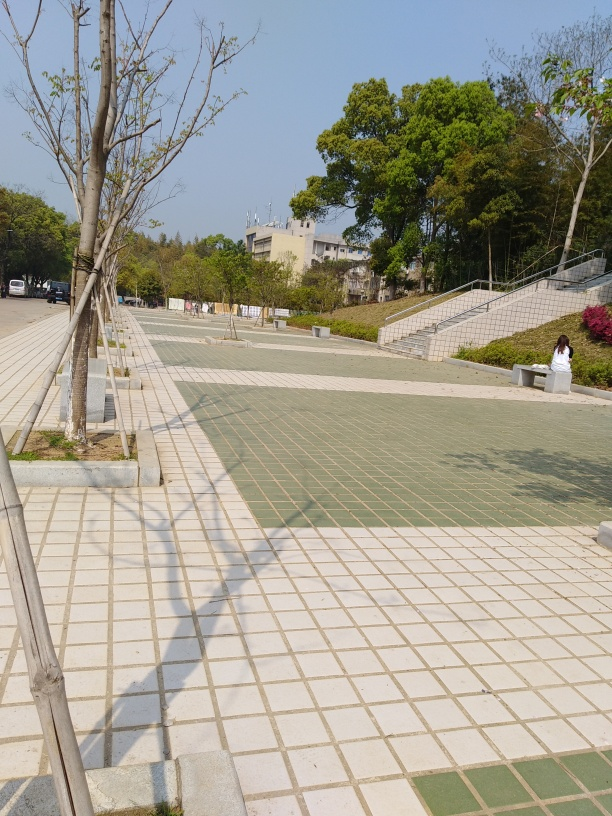Are there any quality issues with this image? The image appears to be of high quality in terms of clarity and resolution. However, there is a notable tilt that gives an impression of imbalance, and the composition could be improved to better focus on a subject or scene. There is also a strong shadow in the foreground which could be deemed distracting. Addressing these aspects could enhance the photograph's overall aesthetic appeal. 